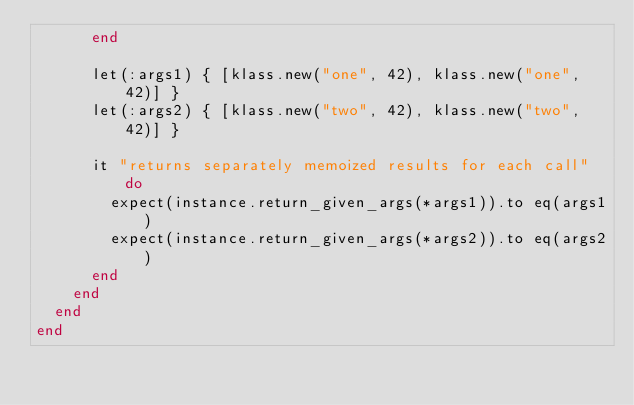<code> <loc_0><loc_0><loc_500><loc_500><_Ruby_>      end

      let(:args1) { [klass.new("one", 42), klass.new("one", 42)] }
      let(:args2) { [klass.new("two", 42), klass.new("two", 42)] }

      it "returns separately memoized results for each call" do
        expect(instance.return_given_args(*args1)).to eq(args1)
        expect(instance.return_given_args(*args2)).to eq(args2)
      end
    end
  end
end
</code> 